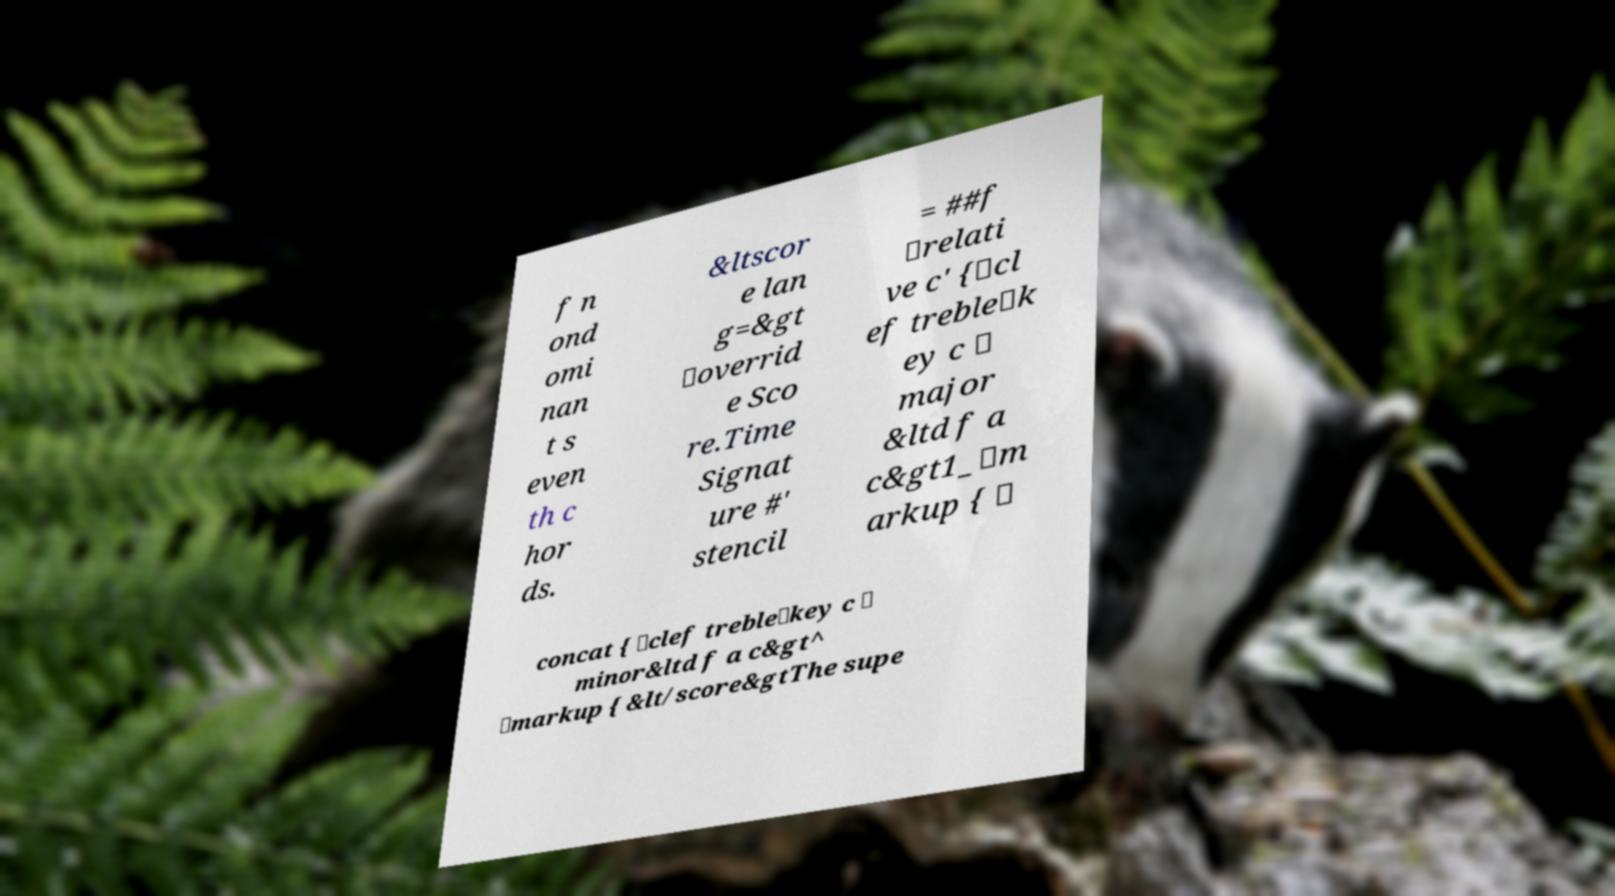Please identify and transcribe the text found in this image. f n ond omi nan t s even th c hor ds. &ltscor e lan g=&gt \overrid e Sco re.Time Signat ure #' stencil = ##f \relati ve c' {\cl ef treble\k ey c \ major &ltd f a c&gt1_\m arkup { \ concat { \clef treble\key c \ minor&ltd f a c&gt^ \markup { &lt/score&gtThe supe 